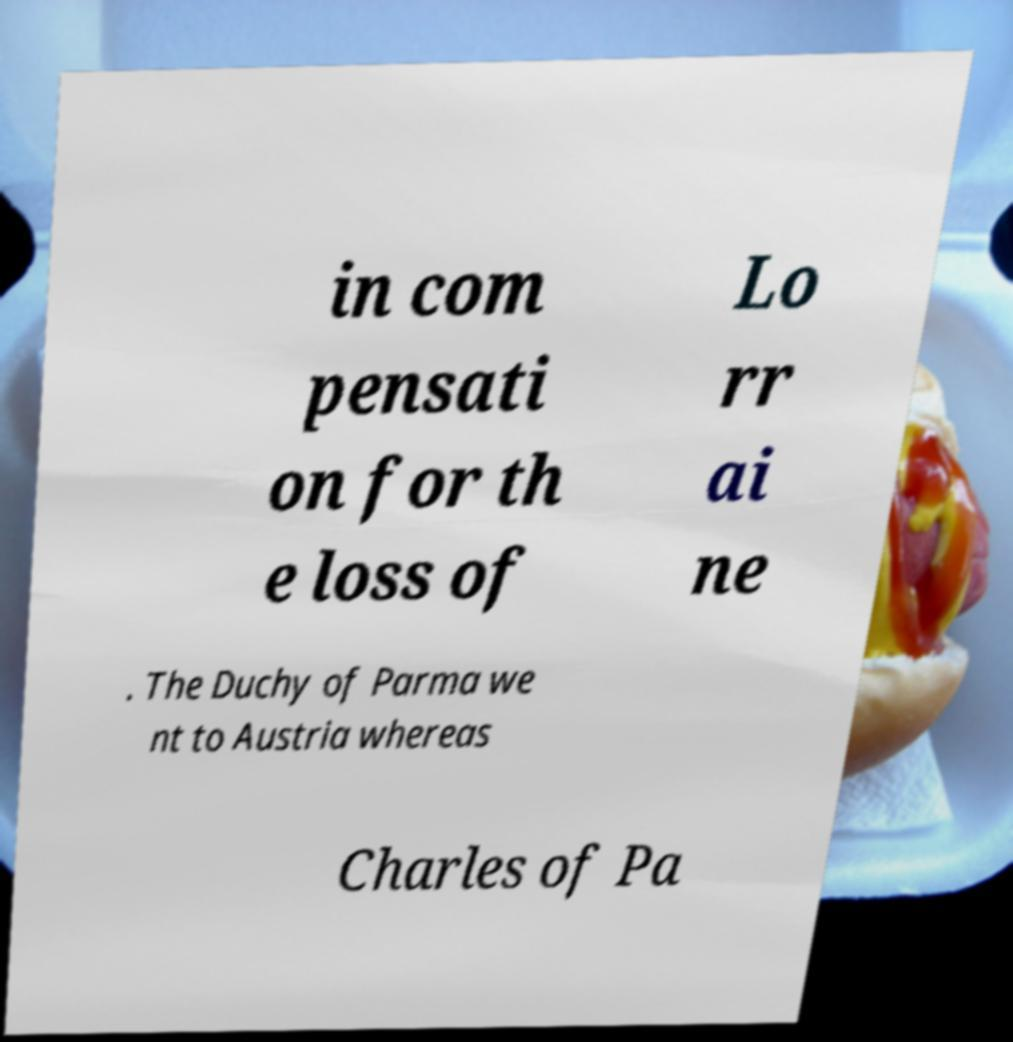Please identify and transcribe the text found in this image. in com pensati on for th e loss of Lo rr ai ne . The Duchy of Parma we nt to Austria whereas Charles of Pa 